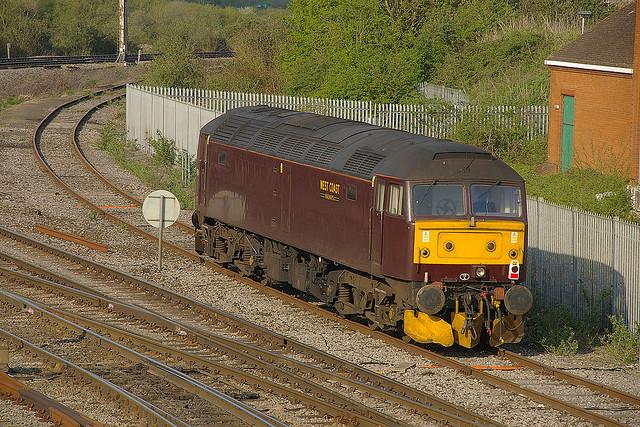Does the train look modern or old fashioned?
Keep it brief. Old fashioned. Is the train facing toward, or away from the camera?
Give a very brief answer. Toward. What color is the train?
Answer briefly. Brown. What powers this engine?
Answer briefly. Electricity. 